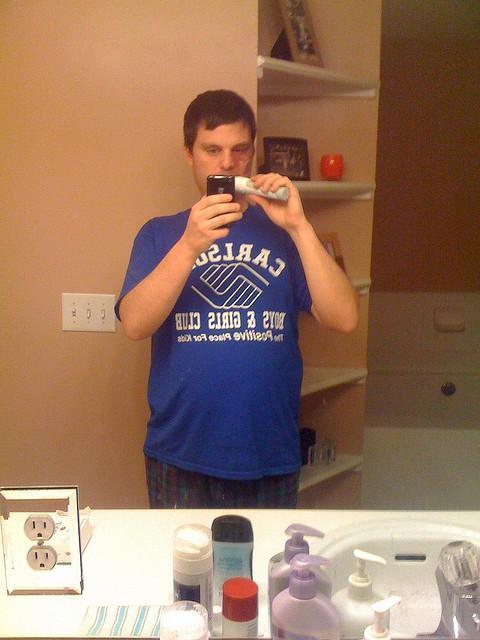How many bottles can be seen?
Give a very brief answer. 3. How many sinks are there?
Give a very brief answer. 1. How many cows a man is holding?
Give a very brief answer. 0. 